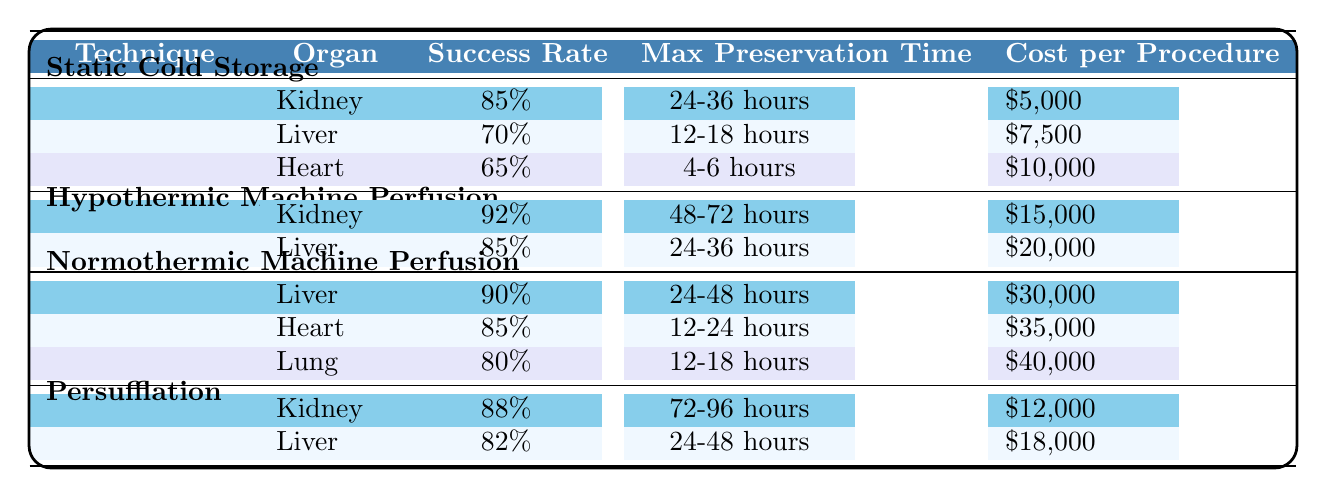What is the success rate of the kidney using Hypothermic Machine Perfusion? The success rate for the kidney under the Hypothermic Machine Perfusion technique is directly given in the table, which states it is 92%.
Answer: 92% Which organ has the lowest success rate when preserved by Static Cold Storage? The table indicates that among the organs preserved by Static Cold Storage, the heart has the lowest success rate at 65%.
Answer: Heart What is the maximum preservation time for the liver using Normothermic Machine Perfusion? According to the table, the maximum preservation time for the liver using Normothermic Machine Perfusion is 24-48 hours.
Answer: 24-48 hours Is the cost for preserving a kidney using Persufflation higher than that for using Static Cold Storage? The cost to preserve a kidney using Persufflation is $12,000, while Static Cold Storage costs $5,000. Since $12,000 is greater than $5,000, the answer is yes.
Answer: Yes What is the average success rate of organs preserved using Normothermic Machine Perfusion? The success rates for the organs preserved using this technique are 90% (liver), 85% (heart), and 80% (lung). Summing these gives 90 + 85 + 80 = 255. There are 3 organs, so the average is 255 / 3 = 85%.
Answer: 85% Which technique offers a maximum preservation time of 72-96 hours for the kidney? Looking at the table, Persufflation is the technique that allows for a maximum preservation time of 72-96 hours for the kidney.
Answer: Persufflation Is the success rate of liver preservation through Hypothermic Machine Perfusion greater than that through Static Cold Storage? The success rate for liver preservation using Hypothermic Machine Perfusion is 85%, while under Static Cold Storage, it is 70%. Since 85% is greater than 70%, the answer is yes.
Answer: Yes Which organ has the highest success rate and how much does it cost to preserve it? The highest success rate is for the kidney under Hypothermic Machine Perfusion at 92%. The cost for this procedure is $15,000.
Answer: Kidney, $15,000 What is the difference in cost between preserving a heart with Normothermic Machine Perfusion and a liver with Hypothermic Machine Perfusion? The cost for preserving a heart with Normothermic Machine Perfusion is $35,000, and the cost for a liver with Hypothermic Machine Perfusion is $20,000. The difference is $35,000 - $20,000 = $15,000.
Answer: $15,000 Which preservation technique has the lowest average cost across the organs listed? To find the average cost of each technique, we calculate: 
- Static Cold Storage: ($5,000 + $7,500 + $10,000)/3 = $7,500
- Hypothermic Machine Perfusion: ($15,000 + $20,000)/2 = $17,500
- Normothermic Machine Perfusion: ($30,000 + $35,000 + $40,000)/3 = $35,000
- Persufflation: ($12,000 + $18,000)/2 = $15,000 
The lowest average cost is from Static Cold Storage at $7,500.
Answer: Static Cold Storage 